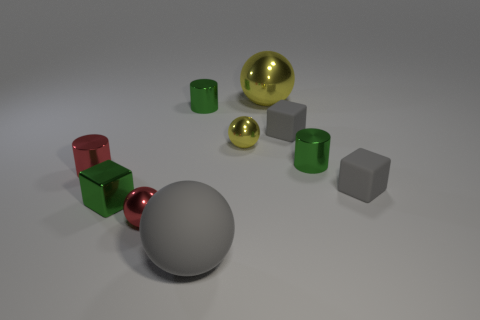There is a big object that is in front of the small red metal thing that is behind the red sphere; what is its color?
Offer a very short reply. Gray. Are there any tiny gray rubber blocks?
Ensure brevity in your answer.  Yes. There is a tiny metal cylinder that is to the left of the large gray thing and right of the green block; what color is it?
Offer a very short reply. Green. Is the size of the green thing that is to the right of the big rubber thing the same as the yellow ball that is behind the tiny yellow metal thing?
Ensure brevity in your answer.  No. How many other objects are the same size as the red shiny sphere?
Provide a short and direct response. 7. There is a small green metallic thing to the right of the tiny yellow sphere; how many cylinders are on the left side of it?
Give a very brief answer. 2. Is the number of yellow metal balls that are on the left side of the red shiny ball less than the number of blue metallic objects?
Your response must be concise. No. What is the shape of the small metallic object that is on the right side of the small ball on the right side of the big thing in front of the big yellow sphere?
Give a very brief answer. Cylinder. Do the small yellow thing and the large metallic thing have the same shape?
Provide a short and direct response. Yes. What number of other objects are the same shape as the small yellow thing?
Provide a short and direct response. 3. 